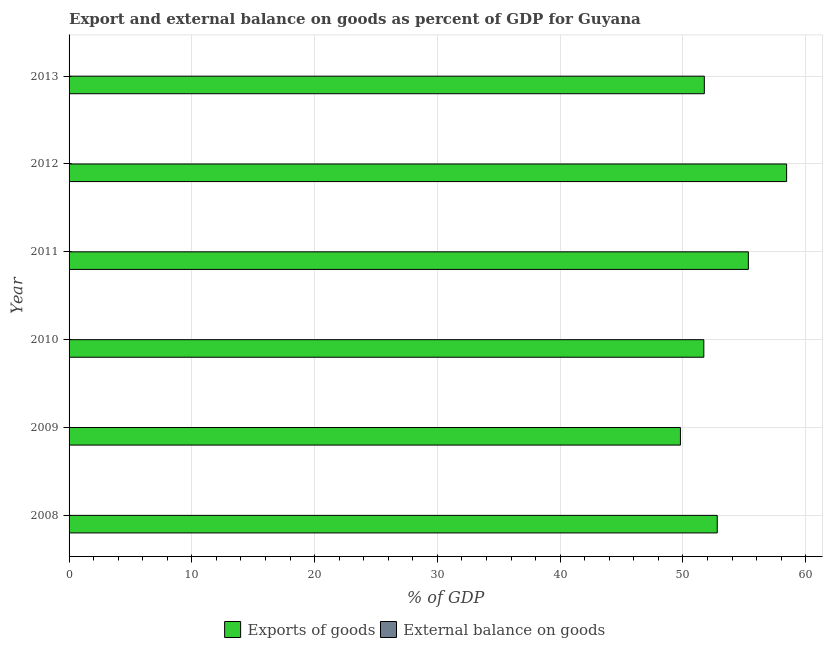Are the number of bars per tick equal to the number of legend labels?
Make the answer very short. No. Are the number of bars on each tick of the Y-axis equal?
Your answer should be very brief. Yes. How many bars are there on the 3rd tick from the top?
Ensure brevity in your answer.  1. How many bars are there on the 2nd tick from the bottom?
Your answer should be compact. 1. In how many cases, is the number of bars for a given year not equal to the number of legend labels?
Your response must be concise. 6. What is the external balance on goods as percentage of gdp in 2008?
Your response must be concise. 0. Across all years, what is the maximum export of goods as percentage of gdp?
Your answer should be very brief. 58.45. Across all years, what is the minimum export of goods as percentage of gdp?
Make the answer very short. 49.8. In which year was the export of goods as percentage of gdp maximum?
Give a very brief answer. 2012. What is the total export of goods as percentage of gdp in the graph?
Your answer should be compact. 319.81. What is the difference between the export of goods as percentage of gdp in 2010 and that in 2013?
Your response must be concise. -0.04. What is the difference between the external balance on goods as percentage of gdp in 2011 and the export of goods as percentage of gdp in 2013?
Offer a terse response. -51.74. What is the average export of goods as percentage of gdp per year?
Provide a short and direct response. 53.3. What is the ratio of the export of goods as percentage of gdp in 2010 to that in 2011?
Offer a very short reply. 0.93. What is the difference between the highest and the second highest export of goods as percentage of gdp?
Offer a terse response. 3.12. What is the difference between the highest and the lowest export of goods as percentage of gdp?
Provide a short and direct response. 8.65. How many bars are there?
Keep it short and to the point. 6. Are the values on the major ticks of X-axis written in scientific E-notation?
Provide a succinct answer. No. Does the graph contain any zero values?
Give a very brief answer. Yes. Does the graph contain grids?
Ensure brevity in your answer.  Yes. Where does the legend appear in the graph?
Ensure brevity in your answer.  Bottom center. What is the title of the graph?
Offer a very short reply. Export and external balance on goods as percent of GDP for Guyana. What is the label or title of the X-axis?
Provide a short and direct response. % of GDP. What is the % of GDP in Exports of goods in 2008?
Your answer should be compact. 52.79. What is the % of GDP in External balance on goods in 2008?
Give a very brief answer. 0. What is the % of GDP in Exports of goods in 2009?
Offer a very short reply. 49.8. What is the % of GDP in Exports of goods in 2010?
Ensure brevity in your answer.  51.7. What is the % of GDP in External balance on goods in 2010?
Your response must be concise. 0. What is the % of GDP of Exports of goods in 2011?
Provide a short and direct response. 55.33. What is the % of GDP of External balance on goods in 2011?
Keep it short and to the point. 0. What is the % of GDP in Exports of goods in 2012?
Give a very brief answer. 58.45. What is the % of GDP of Exports of goods in 2013?
Make the answer very short. 51.74. Across all years, what is the maximum % of GDP in Exports of goods?
Provide a succinct answer. 58.45. Across all years, what is the minimum % of GDP in Exports of goods?
Your answer should be very brief. 49.8. What is the total % of GDP of Exports of goods in the graph?
Your answer should be very brief. 319.81. What is the difference between the % of GDP of Exports of goods in 2008 and that in 2009?
Your answer should be compact. 3. What is the difference between the % of GDP in Exports of goods in 2008 and that in 2010?
Provide a short and direct response. 1.09. What is the difference between the % of GDP of Exports of goods in 2008 and that in 2011?
Make the answer very short. -2.53. What is the difference between the % of GDP in Exports of goods in 2008 and that in 2012?
Give a very brief answer. -5.65. What is the difference between the % of GDP of Exports of goods in 2008 and that in 2013?
Offer a terse response. 1.05. What is the difference between the % of GDP of Exports of goods in 2009 and that in 2010?
Your answer should be very brief. -1.91. What is the difference between the % of GDP of Exports of goods in 2009 and that in 2011?
Your answer should be compact. -5.53. What is the difference between the % of GDP of Exports of goods in 2009 and that in 2012?
Your response must be concise. -8.65. What is the difference between the % of GDP in Exports of goods in 2009 and that in 2013?
Keep it short and to the point. -1.95. What is the difference between the % of GDP in Exports of goods in 2010 and that in 2011?
Your answer should be very brief. -3.63. What is the difference between the % of GDP in Exports of goods in 2010 and that in 2012?
Offer a terse response. -6.74. What is the difference between the % of GDP of Exports of goods in 2010 and that in 2013?
Provide a succinct answer. -0.04. What is the difference between the % of GDP in Exports of goods in 2011 and that in 2012?
Offer a very short reply. -3.12. What is the difference between the % of GDP in Exports of goods in 2011 and that in 2013?
Provide a short and direct response. 3.59. What is the difference between the % of GDP in Exports of goods in 2012 and that in 2013?
Your answer should be compact. 6.7. What is the average % of GDP in Exports of goods per year?
Make the answer very short. 53.3. What is the average % of GDP of External balance on goods per year?
Your response must be concise. 0. What is the ratio of the % of GDP of Exports of goods in 2008 to that in 2009?
Ensure brevity in your answer.  1.06. What is the ratio of the % of GDP in Exports of goods in 2008 to that in 2010?
Provide a short and direct response. 1.02. What is the ratio of the % of GDP in Exports of goods in 2008 to that in 2011?
Your response must be concise. 0.95. What is the ratio of the % of GDP of Exports of goods in 2008 to that in 2012?
Keep it short and to the point. 0.9. What is the ratio of the % of GDP in Exports of goods in 2008 to that in 2013?
Make the answer very short. 1.02. What is the ratio of the % of GDP of Exports of goods in 2009 to that in 2010?
Offer a terse response. 0.96. What is the ratio of the % of GDP in Exports of goods in 2009 to that in 2011?
Offer a terse response. 0.9. What is the ratio of the % of GDP in Exports of goods in 2009 to that in 2012?
Your answer should be very brief. 0.85. What is the ratio of the % of GDP of Exports of goods in 2009 to that in 2013?
Make the answer very short. 0.96. What is the ratio of the % of GDP in Exports of goods in 2010 to that in 2011?
Your answer should be very brief. 0.93. What is the ratio of the % of GDP of Exports of goods in 2010 to that in 2012?
Offer a terse response. 0.88. What is the ratio of the % of GDP in Exports of goods in 2011 to that in 2012?
Offer a terse response. 0.95. What is the ratio of the % of GDP of Exports of goods in 2011 to that in 2013?
Provide a succinct answer. 1.07. What is the ratio of the % of GDP in Exports of goods in 2012 to that in 2013?
Offer a terse response. 1.13. What is the difference between the highest and the second highest % of GDP of Exports of goods?
Make the answer very short. 3.12. What is the difference between the highest and the lowest % of GDP of Exports of goods?
Your answer should be compact. 8.65. 